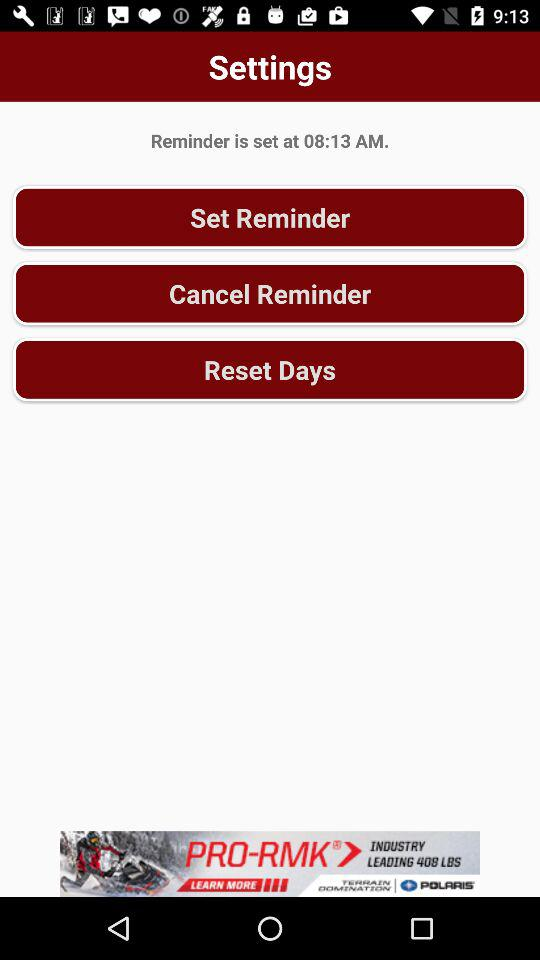At what time is the reminder set? The reminder is set at 8:13 AM. 